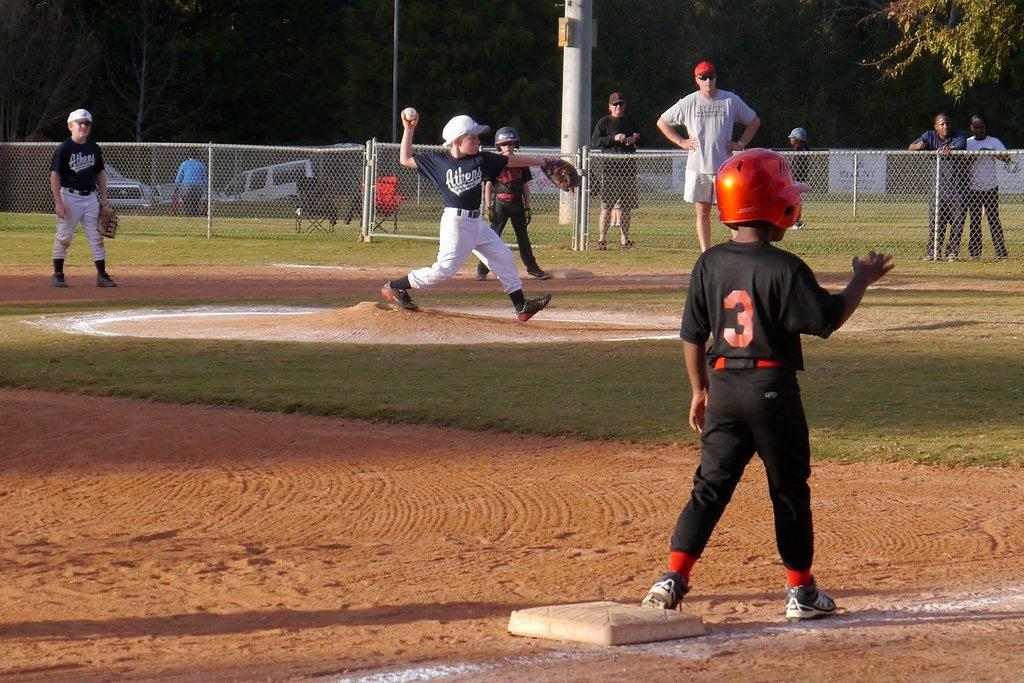<image>
Present a compact description of the photo's key features. a little boy on a baseball plate with a jersey that says 3 